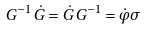Convert formula to latex. <formula><loc_0><loc_0><loc_500><loc_500>G ^ { - 1 } \, \dot { G } = \dot { G } \, G ^ { - 1 } = \dot { \varphi } \sigma</formula> 